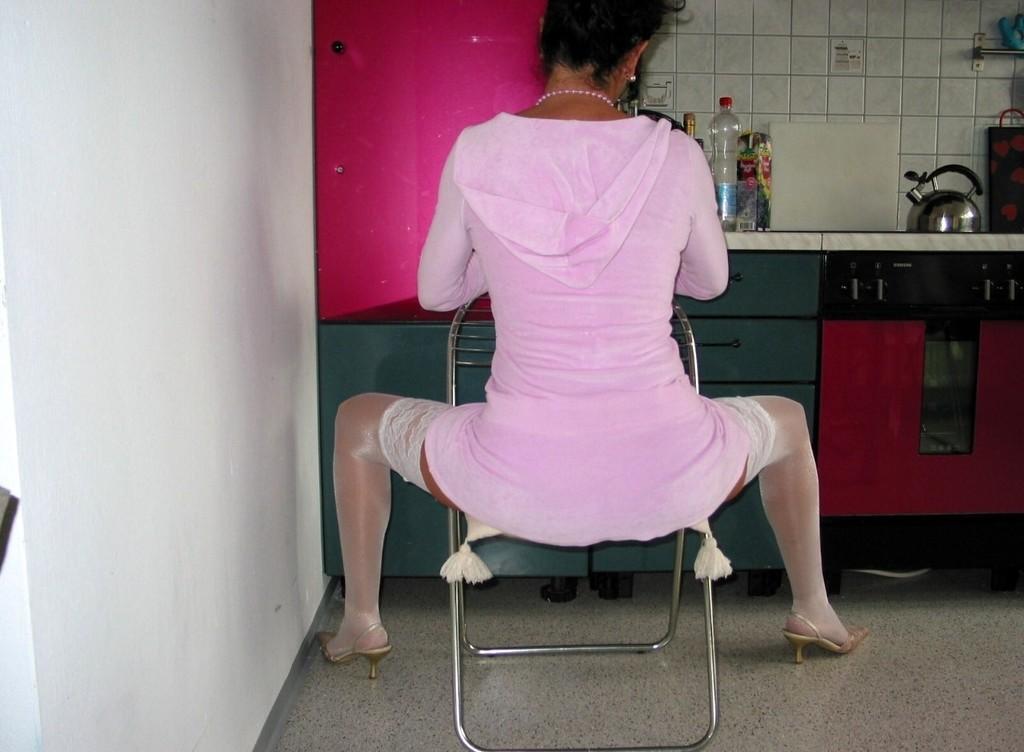Please provide a concise description of this image. In this picture, the woman in the pink dress is sitting on the chair. In front of her, we see a counter top on which water bottle, kettle, chopping board and some other objects are placed. We see a red color cupboard. On the left side, we see a white wall. In the background, we see a wall which is made up of white color tiles. This picture is clicked inside the room. 